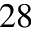<formula> <loc_0><loc_0><loc_500><loc_500>^ { 2 8 }</formula> 